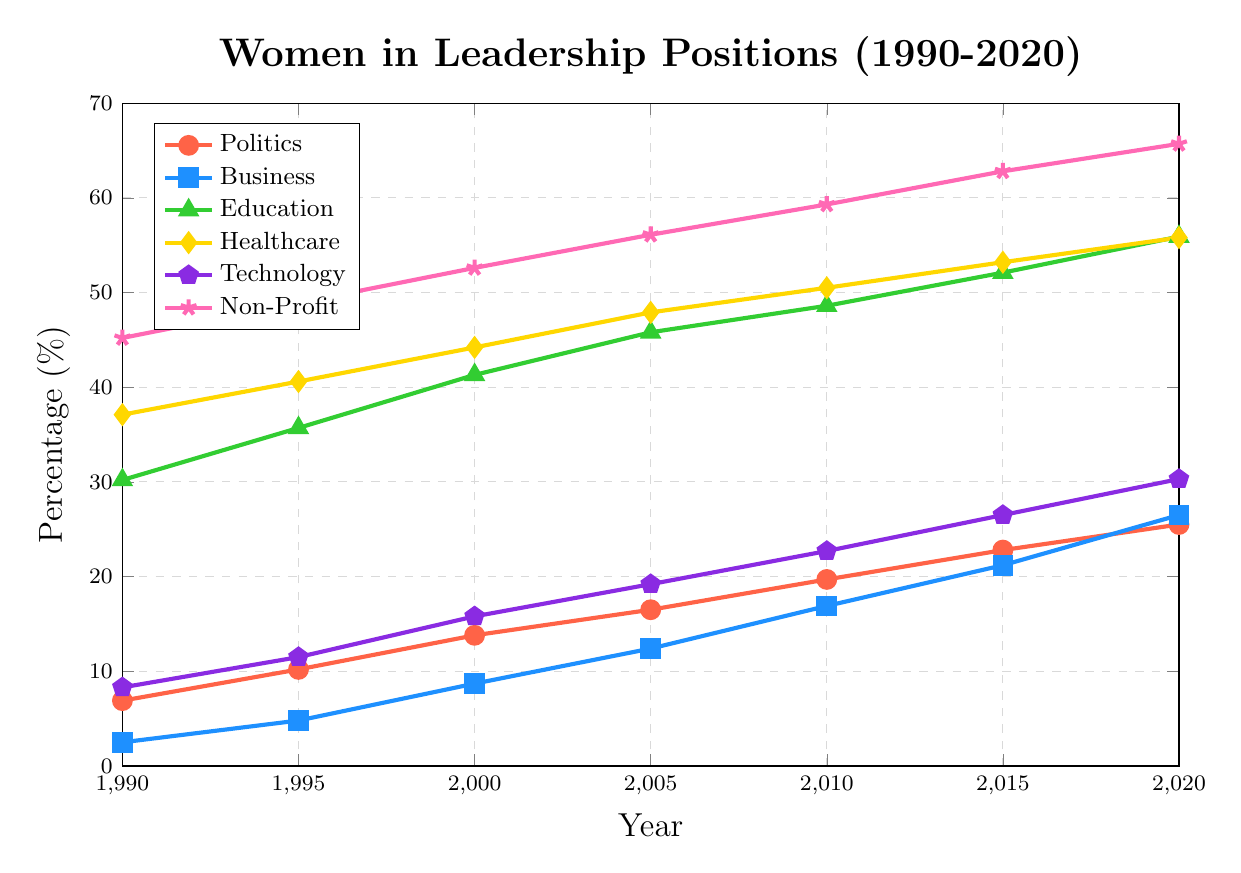What industry had the highest percentage of women in leadership positions in 2020? Look at the heights of the lines in 2020 and compare their final values. The Non-Profit line is the highest, at 65.7%.
Answer: Non-Profit Which industry showed the greatest percentage increase in women in leadership positions from 1990 to 2020? Calculate the difference between the 2020 and 1990 values for each industry: Politics (25.5-6.9=18.6), Business (26.5-2.5=24), Education (55.9-30.2=25.7), Healthcare (55.8-37.1=18.7), Technology (30.3-8.3=22), Non-Profit (65.7-45.2=20.5). The Education industry showed the greatest increase (25.7).
Answer: Education By how many percentage points did the percentage of women in leadership positions increase in Technology from 2000 to 2020? Subtract the 2000 value from the 2020 value for Technology. 30.3% (2020) - 15.8% (2000) = 14.5 percentage points.
Answer: 14.5 percentage points Which industry had the lowest percentage of women in leadership positions in 1990? Look at the starting points of all the lines in 1990. The line for Business starts lowest at 2.5%.
Answer: Business Compare the growth in the percentage of women in leadership between Business and Politics from 1990 to 2010, and determine which had a higher growth. Calculate the growth for each: Business (16.9-2.5=14.4), Politics (19.7-6.9=12.8). Business had a higher growth of 14.4 compared to Politics' 12.8.
Answer: Business Between Healthcare and Education, which had a higher percentage of women in leadership positions in 2005? Compare the 2005 values of Healthcare (47.9%) and Education (45.8%). Healthcare had a higher percentage.
Answer: Healthcare What was the average percentage of women in leadership in Technology over all the years shown? Add the percentages for Technology and divide by the number of years: (8.3 + 11.5 + 15.8 + 19.2 + 22.7 + 26.5 + 30.3) / 7 = 19.04%.
Answer: 19.04% How did the percentage of women in leadership positions in Politics change from 2010 to 2015? Subtract the 2010 value from the 2015 value for Politics. 22.8% (2015) - 19.7% (2010) = 3.1%.
Answer: 3.1% Which industry had a steady increase in the percentage of women in leadership positions over the past 30 years? All lines show an upward trend, but non-profit shows a steady and nearly linear increase from 45.2% in 1990 to 65.7% in 2020.
Answer: Non-Profit 